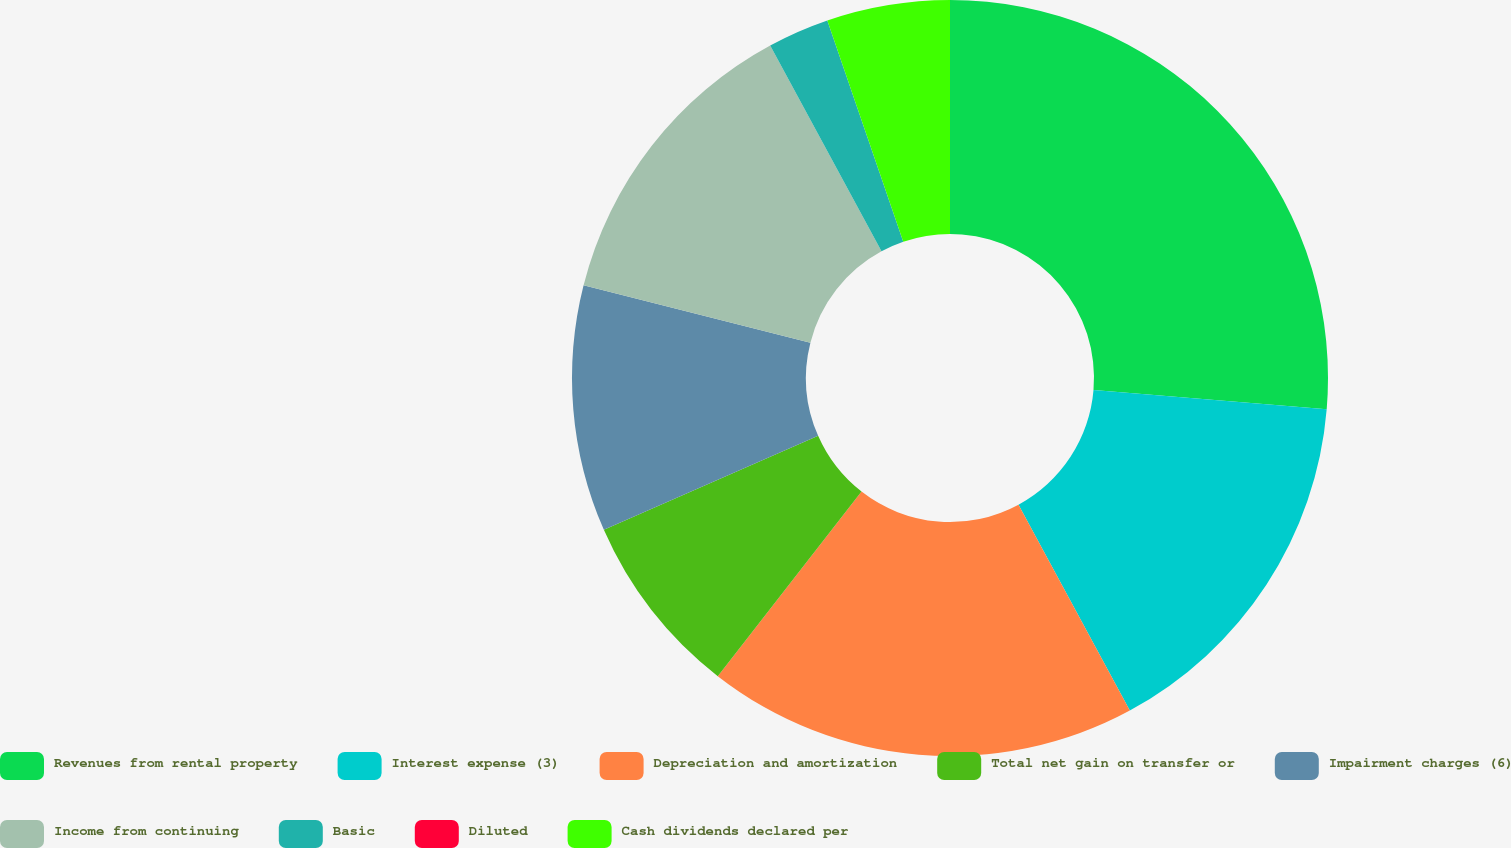<chart> <loc_0><loc_0><loc_500><loc_500><pie_chart><fcel>Revenues from rental property<fcel>Interest expense (3)<fcel>Depreciation and amortization<fcel>Total net gain on transfer or<fcel>Impairment charges (6)<fcel>Income from continuing<fcel>Basic<fcel>Diluted<fcel>Cash dividends declared per<nl><fcel>26.32%<fcel>15.79%<fcel>18.42%<fcel>7.89%<fcel>10.53%<fcel>13.16%<fcel>2.63%<fcel>0.0%<fcel>5.26%<nl></chart> 